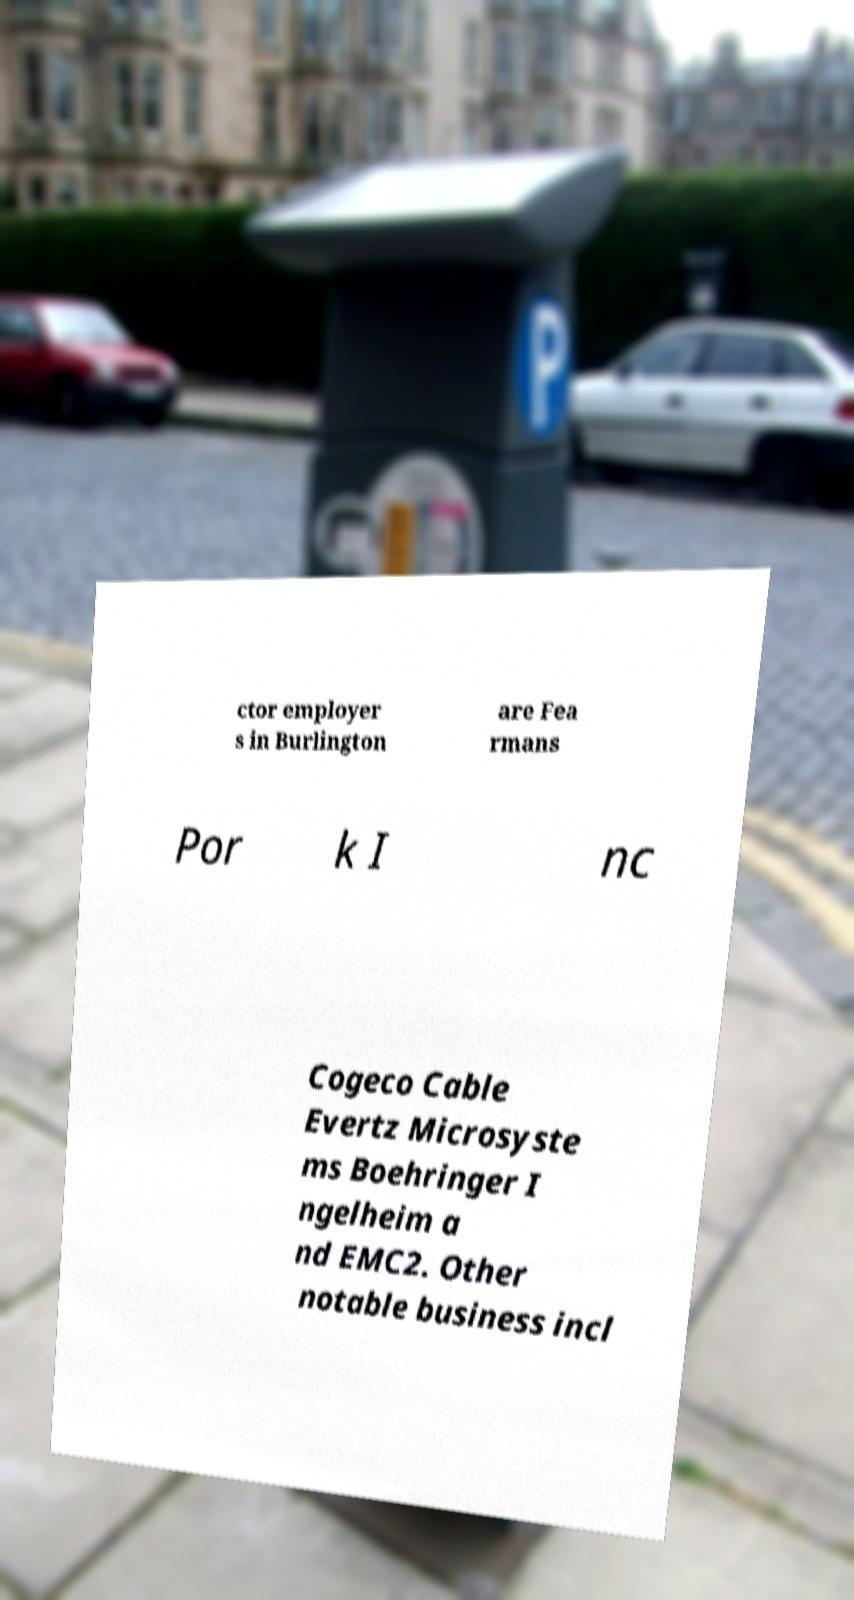What messages or text are displayed in this image? I need them in a readable, typed format. ctor employer s in Burlington are Fea rmans Por k I nc Cogeco Cable Evertz Microsyste ms Boehringer I ngelheim a nd EMC2. Other notable business incl 